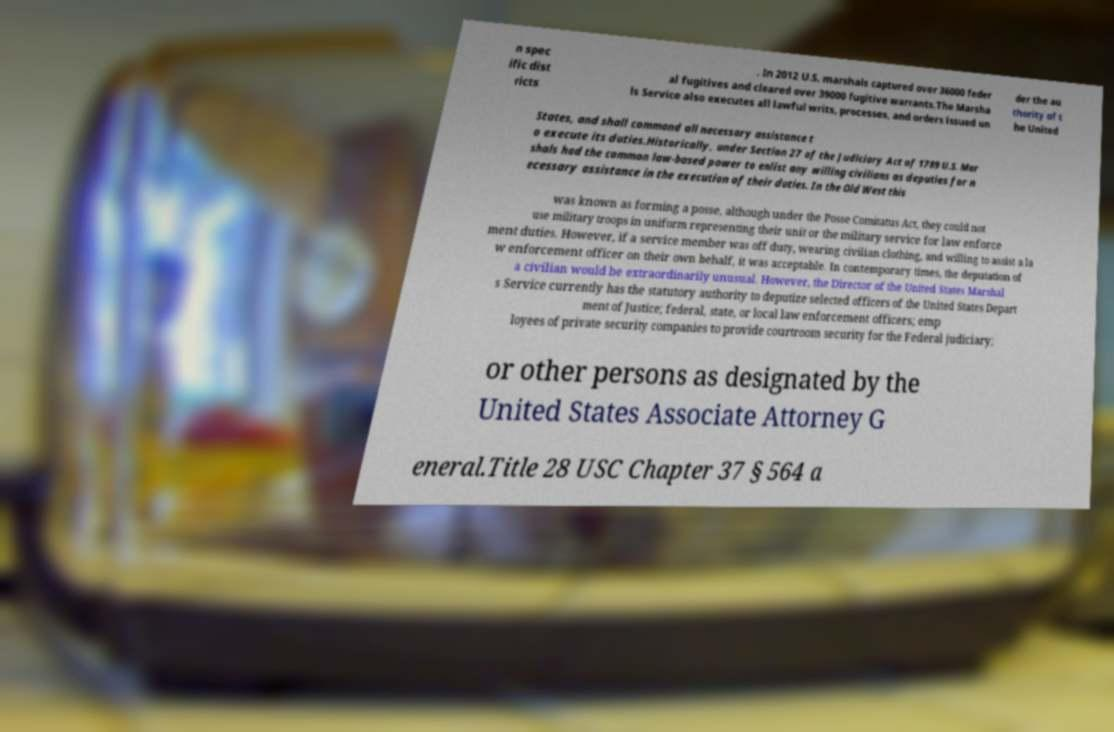Please read and relay the text visible in this image. What does it say? n spec ific dist ricts . In 2012 U.S. marshals captured over 36000 feder al fugitives and cleared over 39000 fugitive warrants.The Marsha ls Service also executes all lawful writs, processes, and orders issued un der the au thority of t he United States, and shall command all necessary assistance t o execute its duties.Historically, under Section 27 of the Judiciary Act of 1789 U.S. Mar shals had the common law-based power to enlist any willing civilians as deputies for n ecessary assistance in the execution of their duties. In the Old West this was known as forming a posse, although under the Posse Comitatus Act, they could not use military troops in uniform representing their unit or the military service for law enforce ment duties. However, if a service member was off duty, wearing civilian clothing, and willing to assist a la w enforcement officer on their own behalf, it was acceptable. In contemporary times, the deputation of a civilian would be extraordinarily unusual. However, the Director of the United States Marshal s Service currently has the statutory authority to deputize selected officers of the United States Depart ment of Justice; federal, state, or local law enforcement officers; emp loyees of private security companies to provide courtroom security for the Federal judiciary; or other persons as designated by the United States Associate Attorney G eneral.Title 28 USC Chapter 37 § 564 a 